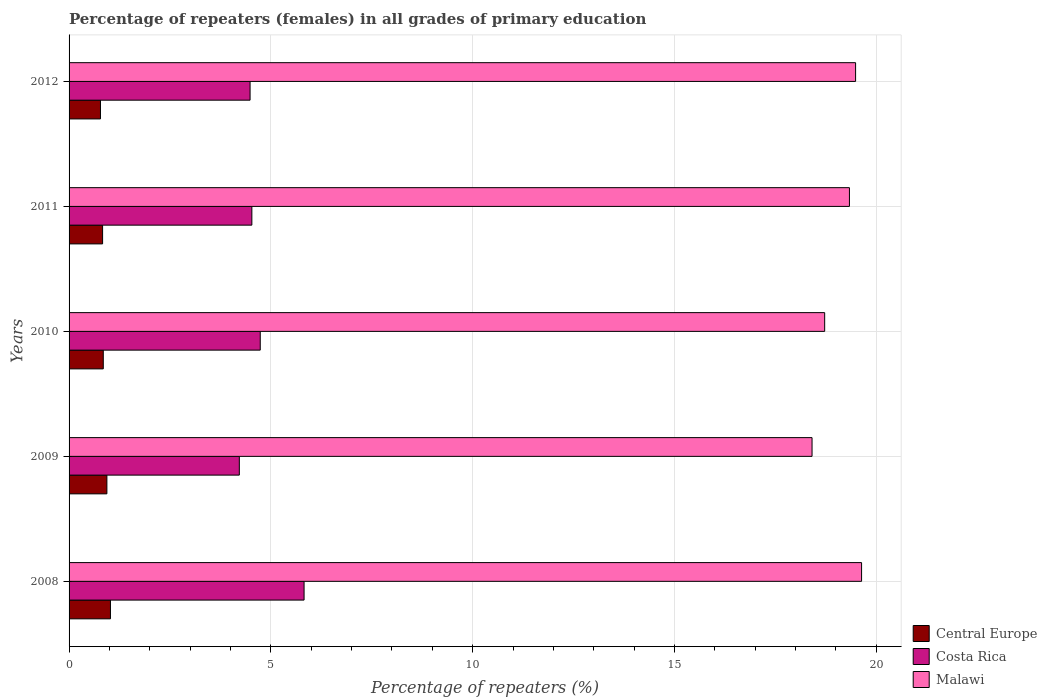Are the number of bars per tick equal to the number of legend labels?
Your response must be concise. Yes. How many bars are there on the 4th tick from the bottom?
Provide a short and direct response. 3. In how many cases, is the number of bars for a given year not equal to the number of legend labels?
Your response must be concise. 0. What is the percentage of repeaters (females) in Malawi in 2009?
Ensure brevity in your answer.  18.41. Across all years, what is the maximum percentage of repeaters (females) in Central Europe?
Offer a terse response. 1.03. Across all years, what is the minimum percentage of repeaters (females) in Costa Rica?
Give a very brief answer. 4.22. In which year was the percentage of repeaters (females) in Central Europe maximum?
Your answer should be compact. 2008. In which year was the percentage of repeaters (females) in Costa Rica minimum?
Your answer should be very brief. 2009. What is the total percentage of repeaters (females) in Central Europe in the graph?
Offer a terse response. 4.42. What is the difference between the percentage of repeaters (females) in Costa Rica in 2009 and that in 2010?
Your response must be concise. -0.52. What is the difference between the percentage of repeaters (females) in Central Europe in 2010 and the percentage of repeaters (females) in Costa Rica in 2008?
Make the answer very short. -4.98. What is the average percentage of repeaters (females) in Central Europe per year?
Your answer should be very brief. 0.88. In the year 2008, what is the difference between the percentage of repeaters (females) in Malawi and percentage of repeaters (females) in Central Europe?
Keep it short and to the point. 18.61. What is the ratio of the percentage of repeaters (females) in Malawi in 2011 to that in 2012?
Provide a succinct answer. 0.99. Is the difference between the percentage of repeaters (females) in Malawi in 2009 and 2012 greater than the difference between the percentage of repeaters (females) in Central Europe in 2009 and 2012?
Make the answer very short. No. What is the difference between the highest and the second highest percentage of repeaters (females) in Central Europe?
Give a very brief answer. 0.09. What is the difference between the highest and the lowest percentage of repeaters (females) in Costa Rica?
Your response must be concise. 1.6. In how many years, is the percentage of repeaters (females) in Malawi greater than the average percentage of repeaters (females) in Malawi taken over all years?
Make the answer very short. 3. Is the sum of the percentage of repeaters (females) in Malawi in 2009 and 2010 greater than the maximum percentage of repeaters (females) in Costa Rica across all years?
Make the answer very short. Yes. What does the 3rd bar from the top in 2012 represents?
Provide a succinct answer. Central Europe. What does the 3rd bar from the bottom in 2008 represents?
Your answer should be very brief. Malawi. How many years are there in the graph?
Offer a terse response. 5. What is the difference between two consecutive major ticks on the X-axis?
Your answer should be very brief. 5. Does the graph contain any zero values?
Your answer should be very brief. No. Does the graph contain grids?
Provide a short and direct response. Yes. How many legend labels are there?
Provide a succinct answer. 3. How are the legend labels stacked?
Your response must be concise. Vertical. What is the title of the graph?
Your answer should be very brief. Percentage of repeaters (females) in all grades of primary education. What is the label or title of the X-axis?
Provide a succinct answer. Percentage of repeaters (%). What is the Percentage of repeaters (%) of Central Europe in 2008?
Offer a very short reply. 1.03. What is the Percentage of repeaters (%) in Costa Rica in 2008?
Your answer should be very brief. 5.82. What is the Percentage of repeaters (%) in Malawi in 2008?
Your answer should be compact. 19.64. What is the Percentage of repeaters (%) of Central Europe in 2009?
Your response must be concise. 0.94. What is the Percentage of repeaters (%) of Costa Rica in 2009?
Ensure brevity in your answer.  4.22. What is the Percentage of repeaters (%) in Malawi in 2009?
Offer a very short reply. 18.41. What is the Percentage of repeaters (%) in Central Europe in 2010?
Offer a terse response. 0.85. What is the Percentage of repeaters (%) of Costa Rica in 2010?
Offer a terse response. 4.74. What is the Percentage of repeaters (%) in Malawi in 2010?
Offer a terse response. 18.72. What is the Percentage of repeaters (%) of Central Europe in 2011?
Offer a terse response. 0.83. What is the Percentage of repeaters (%) of Costa Rica in 2011?
Your answer should be compact. 4.53. What is the Percentage of repeaters (%) of Malawi in 2011?
Keep it short and to the point. 19.34. What is the Percentage of repeaters (%) in Central Europe in 2012?
Your answer should be very brief. 0.78. What is the Percentage of repeaters (%) in Costa Rica in 2012?
Your answer should be compact. 4.48. What is the Percentage of repeaters (%) of Malawi in 2012?
Your answer should be very brief. 19.49. Across all years, what is the maximum Percentage of repeaters (%) in Central Europe?
Give a very brief answer. 1.03. Across all years, what is the maximum Percentage of repeaters (%) in Costa Rica?
Your answer should be very brief. 5.82. Across all years, what is the maximum Percentage of repeaters (%) in Malawi?
Your answer should be compact. 19.64. Across all years, what is the minimum Percentage of repeaters (%) in Central Europe?
Ensure brevity in your answer.  0.78. Across all years, what is the minimum Percentage of repeaters (%) of Costa Rica?
Offer a terse response. 4.22. Across all years, what is the minimum Percentage of repeaters (%) in Malawi?
Give a very brief answer. 18.41. What is the total Percentage of repeaters (%) in Central Europe in the graph?
Keep it short and to the point. 4.42. What is the total Percentage of repeaters (%) of Costa Rica in the graph?
Your answer should be compact. 23.79. What is the total Percentage of repeaters (%) in Malawi in the graph?
Ensure brevity in your answer.  95.59. What is the difference between the Percentage of repeaters (%) of Central Europe in 2008 and that in 2009?
Your answer should be very brief. 0.09. What is the difference between the Percentage of repeaters (%) of Costa Rica in 2008 and that in 2009?
Make the answer very short. 1.6. What is the difference between the Percentage of repeaters (%) in Malawi in 2008 and that in 2009?
Your response must be concise. 1.23. What is the difference between the Percentage of repeaters (%) in Central Europe in 2008 and that in 2010?
Your answer should be compact. 0.18. What is the difference between the Percentage of repeaters (%) of Costa Rica in 2008 and that in 2010?
Provide a short and direct response. 1.09. What is the difference between the Percentage of repeaters (%) of Malawi in 2008 and that in 2010?
Make the answer very short. 0.91. What is the difference between the Percentage of repeaters (%) of Central Europe in 2008 and that in 2011?
Your answer should be compact. 0.19. What is the difference between the Percentage of repeaters (%) in Costa Rica in 2008 and that in 2011?
Your answer should be compact. 1.29. What is the difference between the Percentage of repeaters (%) of Malawi in 2008 and that in 2011?
Your response must be concise. 0.3. What is the difference between the Percentage of repeaters (%) of Central Europe in 2008 and that in 2012?
Your response must be concise. 0.25. What is the difference between the Percentage of repeaters (%) of Costa Rica in 2008 and that in 2012?
Your response must be concise. 1.34. What is the difference between the Percentage of repeaters (%) of Malawi in 2008 and that in 2012?
Provide a short and direct response. 0.15. What is the difference between the Percentage of repeaters (%) in Central Europe in 2009 and that in 2010?
Ensure brevity in your answer.  0.09. What is the difference between the Percentage of repeaters (%) of Costa Rica in 2009 and that in 2010?
Your answer should be compact. -0.52. What is the difference between the Percentage of repeaters (%) of Malawi in 2009 and that in 2010?
Your answer should be compact. -0.31. What is the difference between the Percentage of repeaters (%) of Central Europe in 2009 and that in 2011?
Make the answer very short. 0.11. What is the difference between the Percentage of repeaters (%) of Costa Rica in 2009 and that in 2011?
Give a very brief answer. -0.31. What is the difference between the Percentage of repeaters (%) of Malawi in 2009 and that in 2011?
Your response must be concise. -0.93. What is the difference between the Percentage of repeaters (%) in Central Europe in 2009 and that in 2012?
Keep it short and to the point. 0.16. What is the difference between the Percentage of repeaters (%) in Costa Rica in 2009 and that in 2012?
Make the answer very short. -0.27. What is the difference between the Percentage of repeaters (%) in Malawi in 2009 and that in 2012?
Your response must be concise. -1.08. What is the difference between the Percentage of repeaters (%) in Central Europe in 2010 and that in 2011?
Make the answer very short. 0.02. What is the difference between the Percentage of repeaters (%) of Costa Rica in 2010 and that in 2011?
Offer a terse response. 0.21. What is the difference between the Percentage of repeaters (%) of Malawi in 2010 and that in 2011?
Ensure brevity in your answer.  -0.61. What is the difference between the Percentage of repeaters (%) of Central Europe in 2010 and that in 2012?
Your response must be concise. 0.07. What is the difference between the Percentage of repeaters (%) of Costa Rica in 2010 and that in 2012?
Your answer should be very brief. 0.25. What is the difference between the Percentage of repeaters (%) in Malawi in 2010 and that in 2012?
Your response must be concise. -0.77. What is the difference between the Percentage of repeaters (%) in Central Europe in 2011 and that in 2012?
Ensure brevity in your answer.  0.05. What is the difference between the Percentage of repeaters (%) in Costa Rica in 2011 and that in 2012?
Your answer should be very brief. 0.04. What is the difference between the Percentage of repeaters (%) in Malawi in 2011 and that in 2012?
Keep it short and to the point. -0.15. What is the difference between the Percentage of repeaters (%) of Central Europe in 2008 and the Percentage of repeaters (%) of Costa Rica in 2009?
Make the answer very short. -3.19. What is the difference between the Percentage of repeaters (%) of Central Europe in 2008 and the Percentage of repeaters (%) of Malawi in 2009?
Make the answer very short. -17.38. What is the difference between the Percentage of repeaters (%) in Costa Rica in 2008 and the Percentage of repeaters (%) in Malawi in 2009?
Provide a succinct answer. -12.59. What is the difference between the Percentage of repeaters (%) in Central Europe in 2008 and the Percentage of repeaters (%) in Costa Rica in 2010?
Give a very brief answer. -3.71. What is the difference between the Percentage of repeaters (%) of Central Europe in 2008 and the Percentage of repeaters (%) of Malawi in 2010?
Offer a very short reply. -17.7. What is the difference between the Percentage of repeaters (%) of Costa Rica in 2008 and the Percentage of repeaters (%) of Malawi in 2010?
Offer a very short reply. -12.9. What is the difference between the Percentage of repeaters (%) in Central Europe in 2008 and the Percentage of repeaters (%) in Costa Rica in 2011?
Provide a succinct answer. -3.5. What is the difference between the Percentage of repeaters (%) in Central Europe in 2008 and the Percentage of repeaters (%) in Malawi in 2011?
Offer a very short reply. -18.31. What is the difference between the Percentage of repeaters (%) of Costa Rica in 2008 and the Percentage of repeaters (%) of Malawi in 2011?
Provide a succinct answer. -13.51. What is the difference between the Percentage of repeaters (%) in Central Europe in 2008 and the Percentage of repeaters (%) in Costa Rica in 2012?
Keep it short and to the point. -3.46. What is the difference between the Percentage of repeaters (%) of Central Europe in 2008 and the Percentage of repeaters (%) of Malawi in 2012?
Provide a short and direct response. -18.46. What is the difference between the Percentage of repeaters (%) in Costa Rica in 2008 and the Percentage of repeaters (%) in Malawi in 2012?
Your response must be concise. -13.67. What is the difference between the Percentage of repeaters (%) in Central Europe in 2009 and the Percentage of repeaters (%) in Costa Rica in 2010?
Ensure brevity in your answer.  -3.8. What is the difference between the Percentage of repeaters (%) in Central Europe in 2009 and the Percentage of repeaters (%) in Malawi in 2010?
Your response must be concise. -17.78. What is the difference between the Percentage of repeaters (%) in Costa Rica in 2009 and the Percentage of repeaters (%) in Malawi in 2010?
Keep it short and to the point. -14.5. What is the difference between the Percentage of repeaters (%) of Central Europe in 2009 and the Percentage of repeaters (%) of Costa Rica in 2011?
Provide a short and direct response. -3.59. What is the difference between the Percentage of repeaters (%) in Central Europe in 2009 and the Percentage of repeaters (%) in Malawi in 2011?
Keep it short and to the point. -18.4. What is the difference between the Percentage of repeaters (%) in Costa Rica in 2009 and the Percentage of repeaters (%) in Malawi in 2011?
Provide a short and direct response. -15.12. What is the difference between the Percentage of repeaters (%) of Central Europe in 2009 and the Percentage of repeaters (%) of Costa Rica in 2012?
Provide a short and direct response. -3.55. What is the difference between the Percentage of repeaters (%) of Central Europe in 2009 and the Percentage of repeaters (%) of Malawi in 2012?
Ensure brevity in your answer.  -18.55. What is the difference between the Percentage of repeaters (%) in Costa Rica in 2009 and the Percentage of repeaters (%) in Malawi in 2012?
Provide a short and direct response. -15.27. What is the difference between the Percentage of repeaters (%) of Central Europe in 2010 and the Percentage of repeaters (%) of Costa Rica in 2011?
Provide a short and direct response. -3.68. What is the difference between the Percentage of repeaters (%) in Central Europe in 2010 and the Percentage of repeaters (%) in Malawi in 2011?
Make the answer very short. -18.49. What is the difference between the Percentage of repeaters (%) of Costa Rica in 2010 and the Percentage of repeaters (%) of Malawi in 2011?
Offer a terse response. -14.6. What is the difference between the Percentage of repeaters (%) of Central Europe in 2010 and the Percentage of repeaters (%) of Costa Rica in 2012?
Offer a terse response. -3.64. What is the difference between the Percentage of repeaters (%) of Central Europe in 2010 and the Percentage of repeaters (%) of Malawi in 2012?
Make the answer very short. -18.64. What is the difference between the Percentage of repeaters (%) in Costa Rica in 2010 and the Percentage of repeaters (%) in Malawi in 2012?
Offer a very short reply. -14.75. What is the difference between the Percentage of repeaters (%) of Central Europe in 2011 and the Percentage of repeaters (%) of Costa Rica in 2012?
Provide a short and direct response. -3.65. What is the difference between the Percentage of repeaters (%) of Central Europe in 2011 and the Percentage of repeaters (%) of Malawi in 2012?
Offer a very short reply. -18.66. What is the difference between the Percentage of repeaters (%) in Costa Rica in 2011 and the Percentage of repeaters (%) in Malawi in 2012?
Your answer should be very brief. -14.96. What is the average Percentage of repeaters (%) of Central Europe per year?
Offer a terse response. 0.88. What is the average Percentage of repeaters (%) of Costa Rica per year?
Your answer should be compact. 4.76. What is the average Percentage of repeaters (%) of Malawi per year?
Give a very brief answer. 19.12. In the year 2008, what is the difference between the Percentage of repeaters (%) of Central Europe and Percentage of repeaters (%) of Costa Rica?
Provide a succinct answer. -4.8. In the year 2008, what is the difference between the Percentage of repeaters (%) in Central Europe and Percentage of repeaters (%) in Malawi?
Ensure brevity in your answer.  -18.61. In the year 2008, what is the difference between the Percentage of repeaters (%) in Costa Rica and Percentage of repeaters (%) in Malawi?
Provide a short and direct response. -13.81. In the year 2009, what is the difference between the Percentage of repeaters (%) of Central Europe and Percentage of repeaters (%) of Costa Rica?
Provide a succinct answer. -3.28. In the year 2009, what is the difference between the Percentage of repeaters (%) of Central Europe and Percentage of repeaters (%) of Malawi?
Make the answer very short. -17.47. In the year 2009, what is the difference between the Percentage of repeaters (%) of Costa Rica and Percentage of repeaters (%) of Malawi?
Offer a terse response. -14.19. In the year 2010, what is the difference between the Percentage of repeaters (%) of Central Europe and Percentage of repeaters (%) of Costa Rica?
Provide a short and direct response. -3.89. In the year 2010, what is the difference between the Percentage of repeaters (%) of Central Europe and Percentage of repeaters (%) of Malawi?
Ensure brevity in your answer.  -17.87. In the year 2010, what is the difference between the Percentage of repeaters (%) of Costa Rica and Percentage of repeaters (%) of Malawi?
Your response must be concise. -13.98. In the year 2011, what is the difference between the Percentage of repeaters (%) in Central Europe and Percentage of repeaters (%) in Costa Rica?
Keep it short and to the point. -3.7. In the year 2011, what is the difference between the Percentage of repeaters (%) in Central Europe and Percentage of repeaters (%) in Malawi?
Your answer should be very brief. -18.5. In the year 2011, what is the difference between the Percentage of repeaters (%) in Costa Rica and Percentage of repeaters (%) in Malawi?
Provide a succinct answer. -14.81. In the year 2012, what is the difference between the Percentage of repeaters (%) of Central Europe and Percentage of repeaters (%) of Costa Rica?
Provide a succinct answer. -3.71. In the year 2012, what is the difference between the Percentage of repeaters (%) in Central Europe and Percentage of repeaters (%) in Malawi?
Your response must be concise. -18.71. In the year 2012, what is the difference between the Percentage of repeaters (%) in Costa Rica and Percentage of repeaters (%) in Malawi?
Ensure brevity in your answer.  -15. What is the ratio of the Percentage of repeaters (%) of Central Europe in 2008 to that in 2009?
Your answer should be compact. 1.09. What is the ratio of the Percentage of repeaters (%) of Costa Rica in 2008 to that in 2009?
Your answer should be very brief. 1.38. What is the ratio of the Percentage of repeaters (%) of Malawi in 2008 to that in 2009?
Keep it short and to the point. 1.07. What is the ratio of the Percentage of repeaters (%) in Central Europe in 2008 to that in 2010?
Give a very brief answer. 1.21. What is the ratio of the Percentage of repeaters (%) of Costa Rica in 2008 to that in 2010?
Your answer should be compact. 1.23. What is the ratio of the Percentage of repeaters (%) in Malawi in 2008 to that in 2010?
Provide a succinct answer. 1.05. What is the ratio of the Percentage of repeaters (%) of Central Europe in 2008 to that in 2011?
Your answer should be very brief. 1.23. What is the ratio of the Percentage of repeaters (%) in Malawi in 2008 to that in 2011?
Make the answer very short. 1.02. What is the ratio of the Percentage of repeaters (%) in Central Europe in 2008 to that in 2012?
Your response must be concise. 1.32. What is the ratio of the Percentage of repeaters (%) in Costa Rica in 2008 to that in 2012?
Your answer should be very brief. 1.3. What is the ratio of the Percentage of repeaters (%) of Malawi in 2008 to that in 2012?
Your answer should be compact. 1.01. What is the ratio of the Percentage of repeaters (%) in Central Europe in 2009 to that in 2010?
Keep it short and to the point. 1.11. What is the ratio of the Percentage of repeaters (%) of Costa Rica in 2009 to that in 2010?
Ensure brevity in your answer.  0.89. What is the ratio of the Percentage of repeaters (%) of Malawi in 2009 to that in 2010?
Your answer should be very brief. 0.98. What is the ratio of the Percentage of repeaters (%) in Central Europe in 2009 to that in 2011?
Offer a very short reply. 1.13. What is the ratio of the Percentage of repeaters (%) in Costa Rica in 2009 to that in 2011?
Provide a succinct answer. 0.93. What is the ratio of the Percentage of repeaters (%) in Malawi in 2009 to that in 2011?
Offer a terse response. 0.95. What is the ratio of the Percentage of repeaters (%) in Central Europe in 2009 to that in 2012?
Make the answer very short. 1.2. What is the ratio of the Percentage of repeaters (%) in Costa Rica in 2009 to that in 2012?
Keep it short and to the point. 0.94. What is the ratio of the Percentage of repeaters (%) of Malawi in 2009 to that in 2012?
Keep it short and to the point. 0.94. What is the ratio of the Percentage of repeaters (%) of Central Europe in 2010 to that in 2011?
Provide a short and direct response. 1.02. What is the ratio of the Percentage of repeaters (%) in Costa Rica in 2010 to that in 2011?
Keep it short and to the point. 1.05. What is the ratio of the Percentage of repeaters (%) of Malawi in 2010 to that in 2011?
Provide a succinct answer. 0.97. What is the ratio of the Percentage of repeaters (%) in Central Europe in 2010 to that in 2012?
Provide a short and direct response. 1.09. What is the ratio of the Percentage of repeaters (%) in Costa Rica in 2010 to that in 2012?
Keep it short and to the point. 1.06. What is the ratio of the Percentage of repeaters (%) in Malawi in 2010 to that in 2012?
Your answer should be compact. 0.96. What is the ratio of the Percentage of repeaters (%) in Central Europe in 2011 to that in 2012?
Provide a short and direct response. 1.07. What is the ratio of the Percentage of repeaters (%) in Costa Rica in 2011 to that in 2012?
Provide a short and direct response. 1.01. What is the difference between the highest and the second highest Percentage of repeaters (%) of Central Europe?
Provide a short and direct response. 0.09. What is the difference between the highest and the second highest Percentage of repeaters (%) of Costa Rica?
Keep it short and to the point. 1.09. What is the difference between the highest and the second highest Percentage of repeaters (%) of Malawi?
Your answer should be very brief. 0.15. What is the difference between the highest and the lowest Percentage of repeaters (%) in Central Europe?
Your answer should be very brief. 0.25. What is the difference between the highest and the lowest Percentage of repeaters (%) of Costa Rica?
Keep it short and to the point. 1.6. What is the difference between the highest and the lowest Percentage of repeaters (%) in Malawi?
Ensure brevity in your answer.  1.23. 